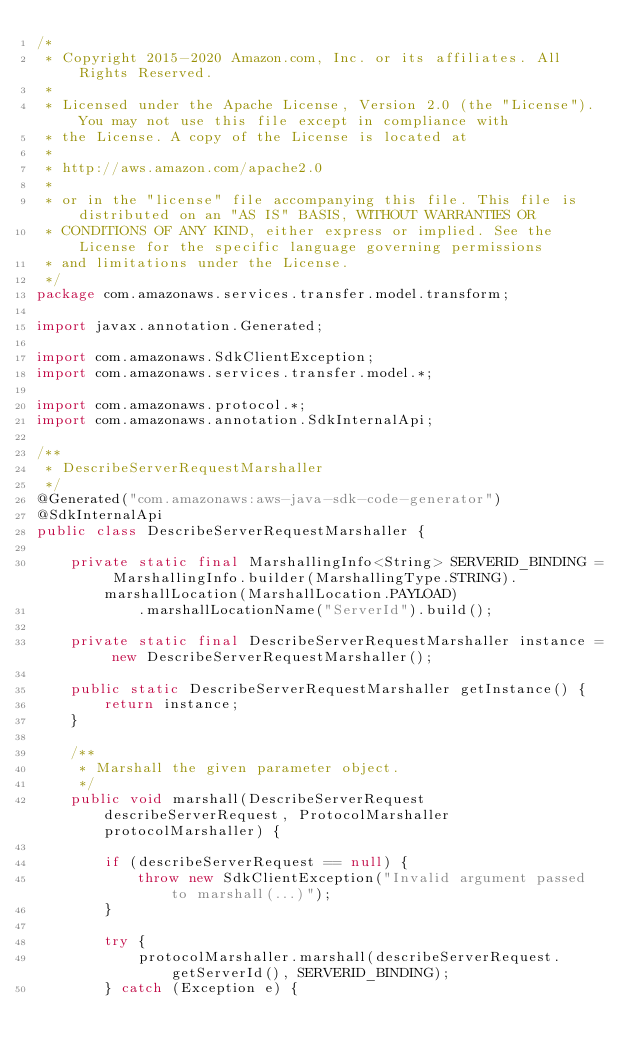Convert code to text. <code><loc_0><loc_0><loc_500><loc_500><_Java_>/*
 * Copyright 2015-2020 Amazon.com, Inc. or its affiliates. All Rights Reserved.
 * 
 * Licensed under the Apache License, Version 2.0 (the "License"). You may not use this file except in compliance with
 * the License. A copy of the License is located at
 * 
 * http://aws.amazon.com/apache2.0
 * 
 * or in the "license" file accompanying this file. This file is distributed on an "AS IS" BASIS, WITHOUT WARRANTIES OR
 * CONDITIONS OF ANY KIND, either express or implied. See the License for the specific language governing permissions
 * and limitations under the License.
 */
package com.amazonaws.services.transfer.model.transform;

import javax.annotation.Generated;

import com.amazonaws.SdkClientException;
import com.amazonaws.services.transfer.model.*;

import com.amazonaws.protocol.*;
import com.amazonaws.annotation.SdkInternalApi;

/**
 * DescribeServerRequestMarshaller
 */
@Generated("com.amazonaws:aws-java-sdk-code-generator")
@SdkInternalApi
public class DescribeServerRequestMarshaller {

    private static final MarshallingInfo<String> SERVERID_BINDING = MarshallingInfo.builder(MarshallingType.STRING).marshallLocation(MarshallLocation.PAYLOAD)
            .marshallLocationName("ServerId").build();

    private static final DescribeServerRequestMarshaller instance = new DescribeServerRequestMarshaller();

    public static DescribeServerRequestMarshaller getInstance() {
        return instance;
    }

    /**
     * Marshall the given parameter object.
     */
    public void marshall(DescribeServerRequest describeServerRequest, ProtocolMarshaller protocolMarshaller) {

        if (describeServerRequest == null) {
            throw new SdkClientException("Invalid argument passed to marshall(...)");
        }

        try {
            protocolMarshaller.marshall(describeServerRequest.getServerId(), SERVERID_BINDING);
        } catch (Exception e) {</code> 